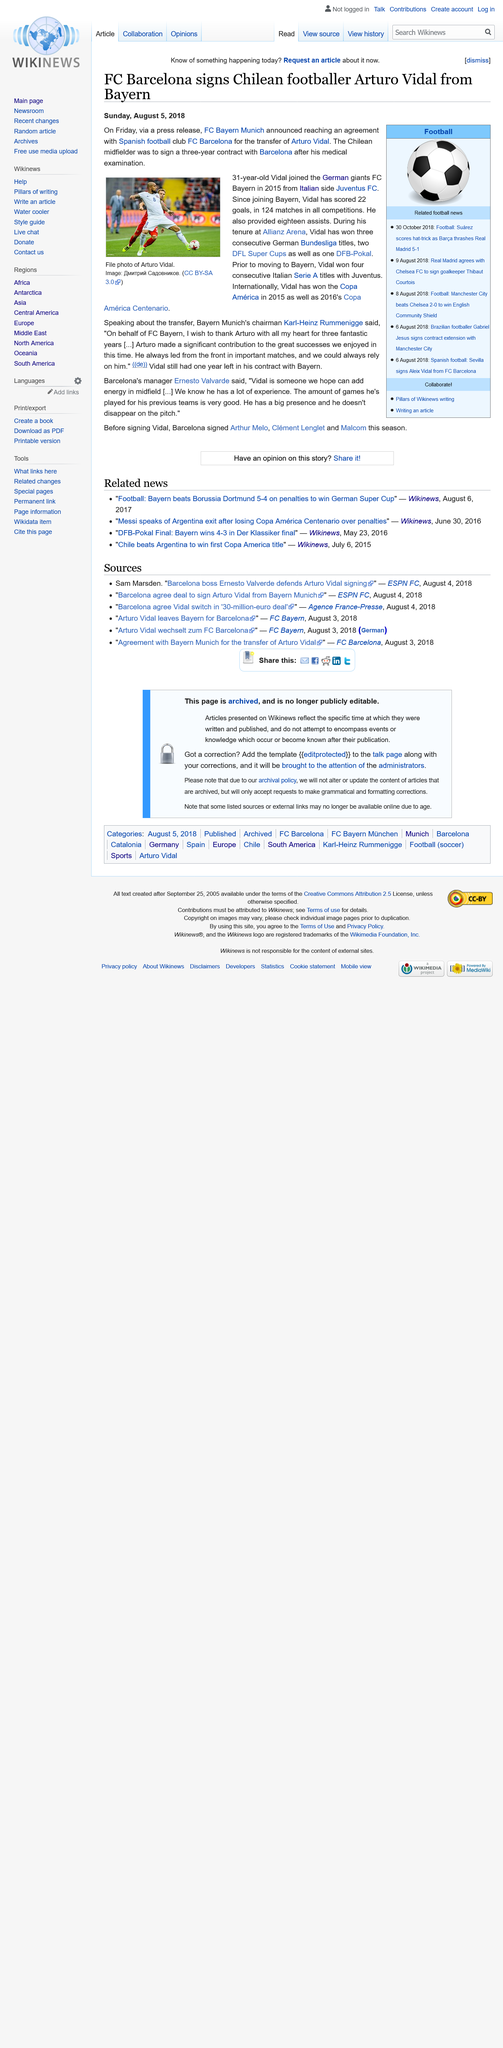Give some essential details in this illustration. FC Barcelona signed Arturo Vidal from Bayern Munich, a prominent German football club. The stadium of FC Bayern Munich is named the Allianz Arena. Arturo Vidal scored 22 goals for FC Bayern Munich. 